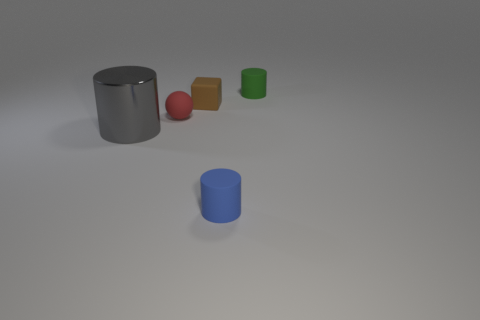Subtract all blue cylinders. How many cylinders are left? 2 Add 1 green matte objects. How many objects exist? 6 Subtract all green cylinders. How many cylinders are left? 2 Subtract 1 blocks. How many blocks are left? 0 Subtract all cylinders. How many objects are left? 2 Subtract all gray cylinders. Subtract all brown balls. How many cylinders are left? 2 Subtract all blue spheres. How many yellow cylinders are left? 0 Add 5 large gray objects. How many large gray objects are left? 6 Add 4 tiny red objects. How many tiny red objects exist? 5 Subtract 1 blue cylinders. How many objects are left? 4 